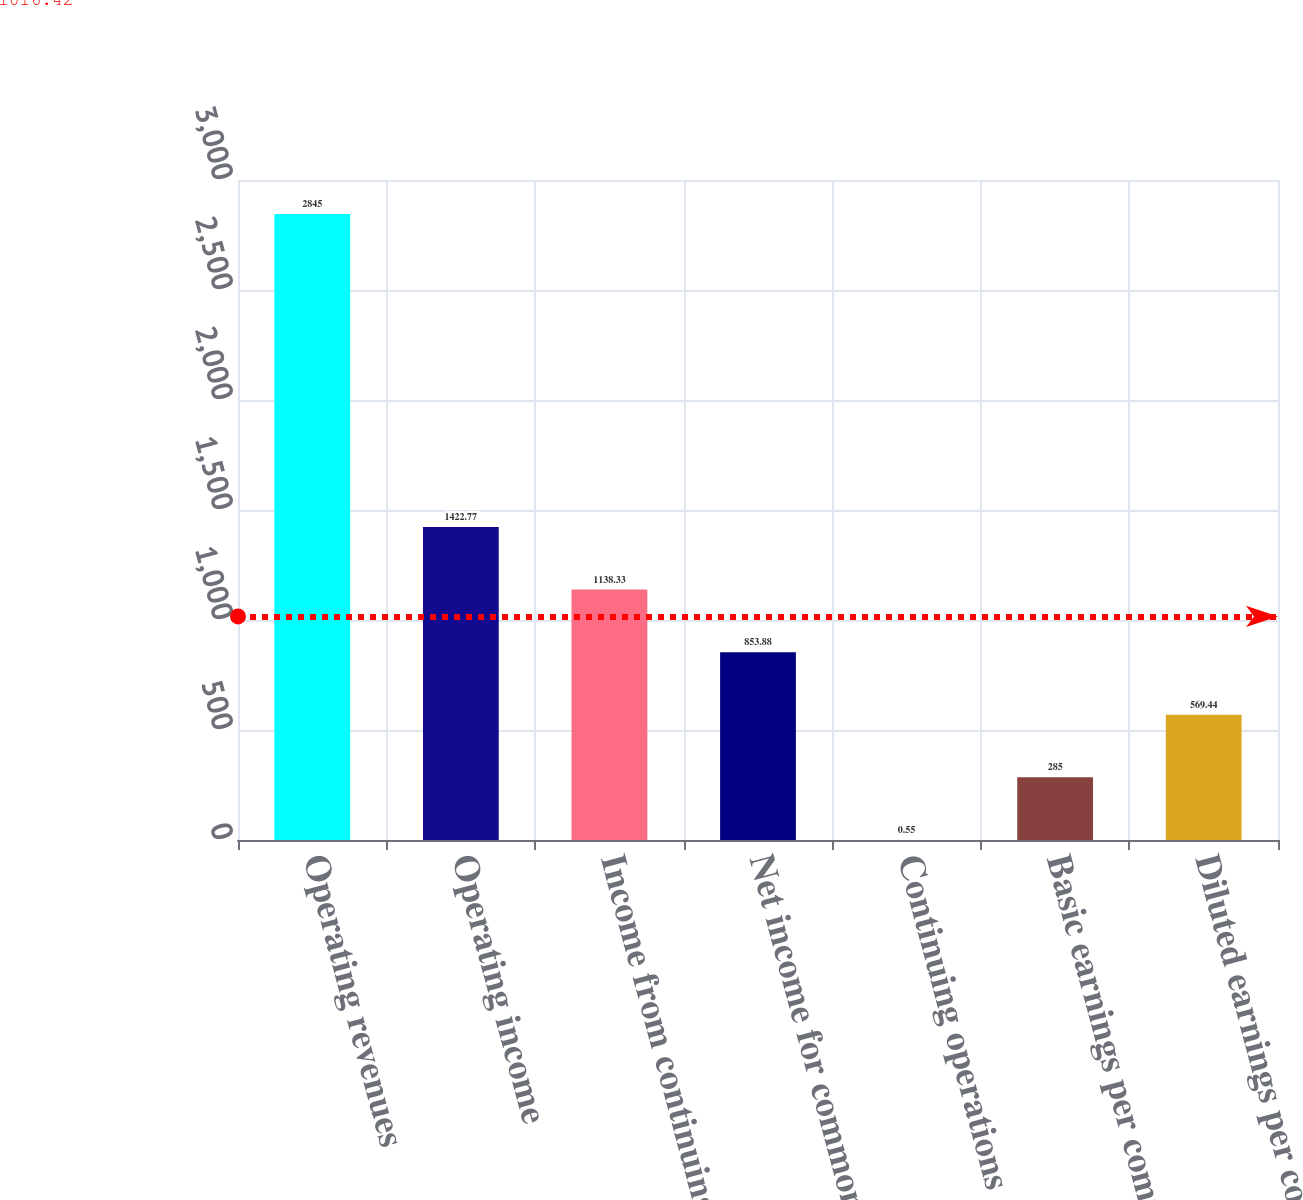Convert chart to OTSL. <chart><loc_0><loc_0><loc_500><loc_500><bar_chart><fcel>Operating revenues<fcel>Operating income<fcel>Income from continuing<fcel>Net income for common stock<fcel>Continuing operations<fcel>Basic earnings per common<fcel>Diluted earnings per common<nl><fcel>2845<fcel>1422.77<fcel>1138.33<fcel>853.88<fcel>0.55<fcel>285<fcel>569.44<nl></chart> 